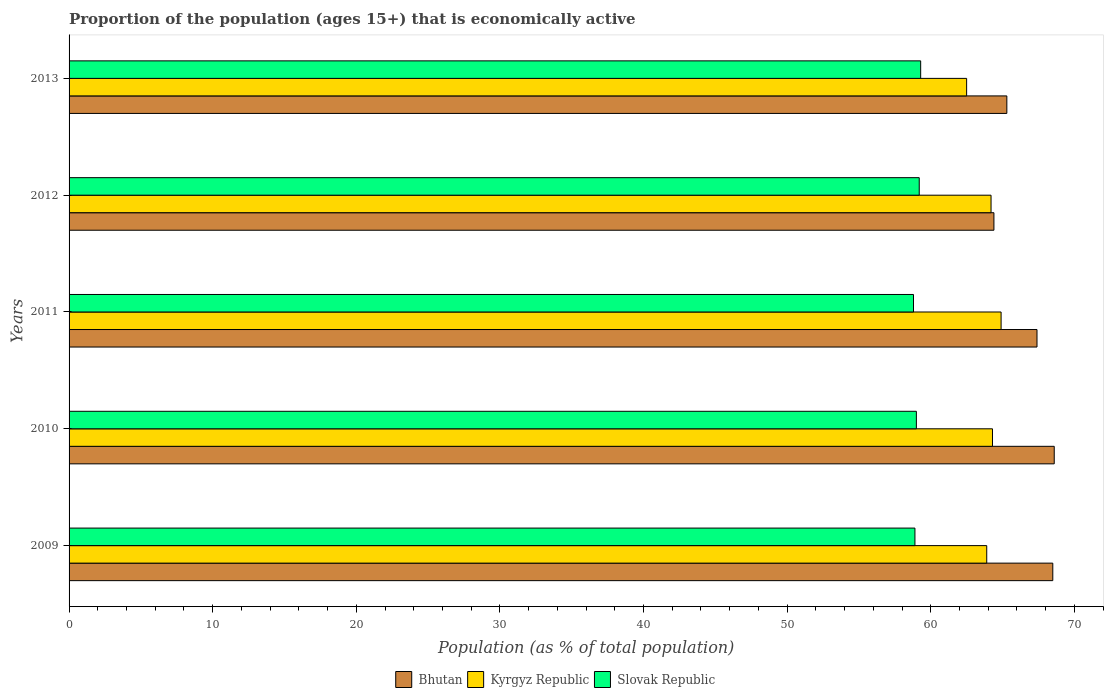How many groups of bars are there?
Your response must be concise. 5. Are the number of bars per tick equal to the number of legend labels?
Your answer should be very brief. Yes. How many bars are there on the 1st tick from the top?
Your answer should be compact. 3. In how many cases, is the number of bars for a given year not equal to the number of legend labels?
Provide a succinct answer. 0. What is the proportion of the population that is economically active in Slovak Republic in 2009?
Offer a terse response. 58.9. Across all years, what is the maximum proportion of the population that is economically active in Bhutan?
Offer a very short reply. 68.6. Across all years, what is the minimum proportion of the population that is economically active in Kyrgyz Republic?
Provide a short and direct response. 62.5. In which year was the proportion of the population that is economically active in Bhutan maximum?
Make the answer very short. 2010. In which year was the proportion of the population that is economically active in Kyrgyz Republic minimum?
Give a very brief answer. 2013. What is the total proportion of the population that is economically active in Bhutan in the graph?
Ensure brevity in your answer.  334.2. What is the difference between the proportion of the population that is economically active in Kyrgyz Republic in 2011 and that in 2012?
Provide a short and direct response. 0.7. What is the difference between the proportion of the population that is economically active in Kyrgyz Republic in 2013 and the proportion of the population that is economically active in Slovak Republic in 2012?
Offer a very short reply. 3.3. What is the average proportion of the population that is economically active in Kyrgyz Republic per year?
Provide a short and direct response. 63.96. In how many years, is the proportion of the population that is economically active in Bhutan greater than 62 %?
Ensure brevity in your answer.  5. What is the ratio of the proportion of the population that is economically active in Bhutan in 2009 to that in 2010?
Your answer should be very brief. 1. Is the proportion of the population that is economically active in Kyrgyz Republic in 2010 less than that in 2012?
Give a very brief answer. No. Is the difference between the proportion of the population that is economically active in Slovak Republic in 2010 and 2012 greater than the difference between the proportion of the population that is economically active in Kyrgyz Republic in 2010 and 2012?
Your answer should be compact. No. What is the difference between the highest and the second highest proportion of the population that is economically active in Kyrgyz Republic?
Your answer should be compact. 0.6. What is the difference between the highest and the lowest proportion of the population that is economically active in Slovak Republic?
Keep it short and to the point. 0.5. What does the 3rd bar from the top in 2011 represents?
Provide a short and direct response. Bhutan. What does the 2nd bar from the bottom in 2011 represents?
Ensure brevity in your answer.  Kyrgyz Republic. Are all the bars in the graph horizontal?
Your response must be concise. Yes. How many years are there in the graph?
Your answer should be compact. 5. Are the values on the major ticks of X-axis written in scientific E-notation?
Your answer should be very brief. No. Does the graph contain grids?
Offer a very short reply. No. Where does the legend appear in the graph?
Your response must be concise. Bottom center. How many legend labels are there?
Give a very brief answer. 3. What is the title of the graph?
Your response must be concise. Proportion of the population (ages 15+) that is economically active. What is the label or title of the X-axis?
Keep it short and to the point. Population (as % of total population). What is the Population (as % of total population) of Bhutan in 2009?
Ensure brevity in your answer.  68.5. What is the Population (as % of total population) of Kyrgyz Republic in 2009?
Ensure brevity in your answer.  63.9. What is the Population (as % of total population) of Slovak Republic in 2009?
Ensure brevity in your answer.  58.9. What is the Population (as % of total population) in Bhutan in 2010?
Ensure brevity in your answer.  68.6. What is the Population (as % of total population) of Kyrgyz Republic in 2010?
Make the answer very short. 64.3. What is the Population (as % of total population) in Bhutan in 2011?
Offer a very short reply. 67.4. What is the Population (as % of total population) in Kyrgyz Republic in 2011?
Provide a short and direct response. 64.9. What is the Population (as % of total population) in Slovak Republic in 2011?
Offer a terse response. 58.8. What is the Population (as % of total population) in Bhutan in 2012?
Your answer should be compact. 64.4. What is the Population (as % of total population) of Kyrgyz Republic in 2012?
Give a very brief answer. 64.2. What is the Population (as % of total population) in Slovak Republic in 2012?
Provide a short and direct response. 59.2. What is the Population (as % of total population) of Bhutan in 2013?
Offer a very short reply. 65.3. What is the Population (as % of total population) in Kyrgyz Republic in 2013?
Provide a succinct answer. 62.5. What is the Population (as % of total population) in Slovak Republic in 2013?
Give a very brief answer. 59.3. Across all years, what is the maximum Population (as % of total population) in Bhutan?
Give a very brief answer. 68.6. Across all years, what is the maximum Population (as % of total population) of Kyrgyz Republic?
Ensure brevity in your answer.  64.9. Across all years, what is the maximum Population (as % of total population) of Slovak Republic?
Offer a very short reply. 59.3. Across all years, what is the minimum Population (as % of total population) in Bhutan?
Give a very brief answer. 64.4. Across all years, what is the minimum Population (as % of total population) of Kyrgyz Republic?
Provide a short and direct response. 62.5. Across all years, what is the minimum Population (as % of total population) of Slovak Republic?
Keep it short and to the point. 58.8. What is the total Population (as % of total population) in Bhutan in the graph?
Ensure brevity in your answer.  334.2. What is the total Population (as % of total population) of Kyrgyz Republic in the graph?
Your answer should be very brief. 319.8. What is the total Population (as % of total population) in Slovak Republic in the graph?
Provide a short and direct response. 295.2. What is the difference between the Population (as % of total population) of Bhutan in 2009 and that in 2010?
Your answer should be compact. -0.1. What is the difference between the Population (as % of total population) in Bhutan in 2009 and that in 2011?
Keep it short and to the point. 1.1. What is the difference between the Population (as % of total population) of Slovak Republic in 2009 and that in 2011?
Your response must be concise. 0.1. What is the difference between the Population (as % of total population) in Bhutan in 2009 and that in 2012?
Give a very brief answer. 4.1. What is the difference between the Population (as % of total population) in Kyrgyz Republic in 2009 and that in 2012?
Keep it short and to the point. -0.3. What is the difference between the Population (as % of total population) in Slovak Republic in 2009 and that in 2012?
Offer a terse response. -0.3. What is the difference between the Population (as % of total population) in Bhutan in 2009 and that in 2013?
Keep it short and to the point. 3.2. What is the difference between the Population (as % of total population) of Bhutan in 2010 and that in 2011?
Give a very brief answer. 1.2. What is the difference between the Population (as % of total population) in Bhutan in 2010 and that in 2013?
Give a very brief answer. 3.3. What is the difference between the Population (as % of total population) of Kyrgyz Republic in 2010 and that in 2013?
Your response must be concise. 1.8. What is the difference between the Population (as % of total population) in Slovak Republic in 2010 and that in 2013?
Keep it short and to the point. -0.3. What is the difference between the Population (as % of total population) of Bhutan in 2011 and that in 2012?
Ensure brevity in your answer.  3. What is the difference between the Population (as % of total population) in Kyrgyz Republic in 2011 and that in 2012?
Give a very brief answer. 0.7. What is the difference between the Population (as % of total population) in Slovak Republic in 2011 and that in 2013?
Your answer should be compact. -0.5. What is the difference between the Population (as % of total population) of Bhutan in 2009 and the Population (as % of total population) of Kyrgyz Republic in 2010?
Give a very brief answer. 4.2. What is the difference between the Population (as % of total population) of Bhutan in 2009 and the Population (as % of total population) of Slovak Republic in 2010?
Your answer should be compact. 9.5. What is the difference between the Population (as % of total population) in Kyrgyz Republic in 2009 and the Population (as % of total population) in Slovak Republic in 2010?
Ensure brevity in your answer.  4.9. What is the difference between the Population (as % of total population) of Bhutan in 2009 and the Population (as % of total population) of Kyrgyz Republic in 2012?
Offer a terse response. 4.3. What is the difference between the Population (as % of total population) of Bhutan in 2009 and the Population (as % of total population) of Slovak Republic in 2012?
Your answer should be very brief. 9.3. What is the difference between the Population (as % of total population) of Bhutan in 2009 and the Population (as % of total population) of Kyrgyz Republic in 2013?
Make the answer very short. 6. What is the difference between the Population (as % of total population) of Bhutan in 2009 and the Population (as % of total population) of Slovak Republic in 2013?
Your answer should be compact. 9.2. What is the difference between the Population (as % of total population) of Kyrgyz Republic in 2009 and the Population (as % of total population) of Slovak Republic in 2013?
Keep it short and to the point. 4.6. What is the difference between the Population (as % of total population) of Bhutan in 2010 and the Population (as % of total population) of Slovak Republic in 2011?
Your answer should be very brief. 9.8. What is the difference between the Population (as % of total population) of Bhutan in 2010 and the Population (as % of total population) of Slovak Republic in 2012?
Ensure brevity in your answer.  9.4. What is the difference between the Population (as % of total population) in Kyrgyz Republic in 2010 and the Population (as % of total population) in Slovak Republic in 2012?
Ensure brevity in your answer.  5.1. What is the difference between the Population (as % of total population) in Kyrgyz Republic in 2010 and the Population (as % of total population) in Slovak Republic in 2013?
Offer a terse response. 5. What is the difference between the Population (as % of total population) in Kyrgyz Republic in 2011 and the Population (as % of total population) in Slovak Republic in 2012?
Offer a very short reply. 5.7. What is the difference between the Population (as % of total population) of Bhutan in 2011 and the Population (as % of total population) of Kyrgyz Republic in 2013?
Your answer should be very brief. 4.9. What is the difference between the Population (as % of total population) of Bhutan in 2011 and the Population (as % of total population) of Slovak Republic in 2013?
Keep it short and to the point. 8.1. What is the average Population (as % of total population) in Bhutan per year?
Make the answer very short. 66.84. What is the average Population (as % of total population) in Kyrgyz Republic per year?
Give a very brief answer. 63.96. What is the average Population (as % of total population) of Slovak Republic per year?
Keep it short and to the point. 59.04. In the year 2009, what is the difference between the Population (as % of total population) of Bhutan and Population (as % of total population) of Kyrgyz Republic?
Offer a very short reply. 4.6. In the year 2009, what is the difference between the Population (as % of total population) in Kyrgyz Republic and Population (as % of total population) in Slovak Republic?
Provide a short and direct response. 5. In the year 2010, what is the difference between the Population (as % of total population) in Bhutan and Population (as % of total population) in Kyrgyz Republic?
Give a very brief answer. 4.3. In the year 2010, what is the difference between the Population (as % of total population) of Bhutan and Population (as % of total population) of Slovak Republic?
Your response must be concise. 9.6. In the year 2011, what is the difference between the Population (as % of total population) in Kyrgyz Republic and Population (as % of total population) in Slovak Republic?
Provide a succinct answer. 6.1. In the year 2012, what is the difference between the Population (as % of total population) of Bhutan and Population (as % of total population) of Slovak Republic?
Offer a terse response. 5.2. In the year 2012, what is the difference between the Population (as % of total population) of Kyrgyz Republic and Population (as % of total population) of Slovak Republic?
Provide a short and direct response. 5. In the year 2013, what is the difference between the Population (as % of total population) in Bhutan and Population (as % of total population) in Kyrgyz Republic?
Provide a succinct answer. 2.8. In the year 2013, what is the difference between the Population (as % of total population) in Kyrgyz Republic and Population (as % of total population) in Slovak Republic?
Your response must be concise. 3.2. What is the ratio of the Population (as % of total population) in Kyrgyz Republic in 2009 to that in 2010?
Offer a very short reply. 0.99. What is the ratio of the Population (as % of total population) of Bhutan in 2009 to that in 2011?
Ensure brevity in your answer.  1.02. What is the ratio of the Population (as % of total population) in Kyrgyz Republic in 2009 to that in 2011?
Keep it short and to the point. 0.98. What is the ratio of the Population (as % of total population) in Slovak Republic in 2009 to that in 2011?
Your answer should be very brief. 1. What is the ratio of the Population (as % of total population) of Bhutan in 2009 to that in 2012?
Keep it short and to the point. 1.06. What is the ratio of the Population (as % of total population) in Kyrgyz Republic in 2009 to that in 2012?
Make the answer very short. 1. What is the ratio of the Population (as % of total population) in Bhutan in 2009 to that in 2013?
Your answer should be compact. 1.05. What is the ratio of the Population (as % of total population) in Kyrgyz Republic in 2009 to that in 2013?
Your answer should be very brief. 1.02. What is the ratio of the Population (as % of total population) in Bhutan in 2010 to that in 2011?
Give a very brief answer. 1.02. What is the ratio of the Population (as % of total population) of Kyrgyz Republic in 2010 to that in 2011?
Offer a terse response. 0.99. What is the ratio of the Population (as % of total population) in Slovak Republic in 2010 to that in 2011?
Provide a succinct answer. 1. What is the ratio of the Population (as % of total population) in Bhutan in 2010 to that in 2012?
Ensure brevity in your answer.  1.07. What is the ratio of the Population (as % of total population) of Kyrgyz Republic in 2010 to that in 2012?
Your answer should be compact. 1. What is the ratio of the Population (as % of total population) in Bhutan in 2010 to that in 2013?
Offer a terse response. 1.05. What is the ratio of the Population (as % of total population) of Kyrgyz Republic in 2010 to that in 2013?
Your response must be concise. 1.03. What is the ratio of the Population (as % of total population) of Bhutan in 2011 to that in 2012?
Provide a succinct answer. 1.05. What is the ratio of the Population (as % of total population) of Kyrgyz Republic in 2011 to that in 2012?
Your answer should be compact. 1.01. What is the ratio of the Population (as % of total population) in Slovak Republic in 2011 to that in 2012?
Make the answer very short. 0.99. What is the ratio of the Population (as % of total population) of Bhutan in 2011 to that in 2013?
Offer a terse response. 1.03. What is the ratio of the Population (as % of total population) of Kyrgyz Republic in 2011 to that in 2013?
Offer a terse response. 1.04. What is the ratio of the Population (as % of total population) of Slovak Republic in 2011 to that in 2013?
Offer a terse response. 0.99. What is the ratio of the Population (as % of total population) in Bhutan in 2012 to that in 2013?
Ensure brevity in your answer.  0.99. What is the ratio of the Population (as % of total population) in Kyrgyz Republic in 2012 to that in 2013?
Offer a very short reply. 1.03. What is the ratio of the Population (as % of total population) in Slovak Republic in 2012 to that in 2013?
Your response must be concise. 1. What is the difference between the highest and the second highest Population (as % of total population) of Bhutan?
Your response must be concise. 0.1. What is the difference between the highest and the second highest Population (as % of total population) in Kyrgyz Republic?
Your answer should be compact. 0.6. What is the difference between the highest and the lowest Population (as % of total population) in Bhutan?
Provide a short and direct response. 4.2. What is the difference between the highest and the lowest Population (as % of total population) of Slovak Republic?
Give a very brief answer. 0.5. 